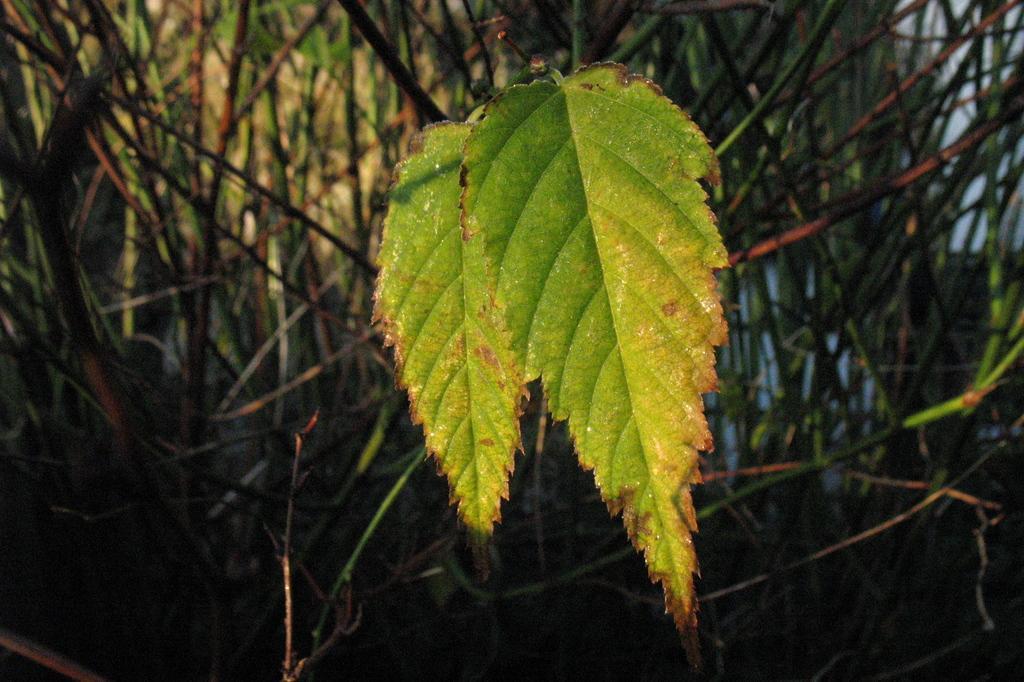How would you summarize this image in a sentence or two? In this image in the front there are leaves. In the background there are branches of plants. 